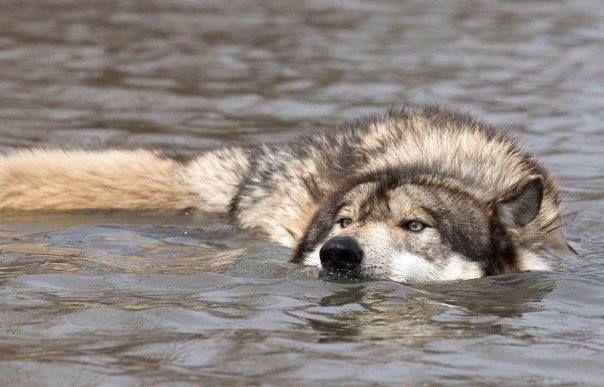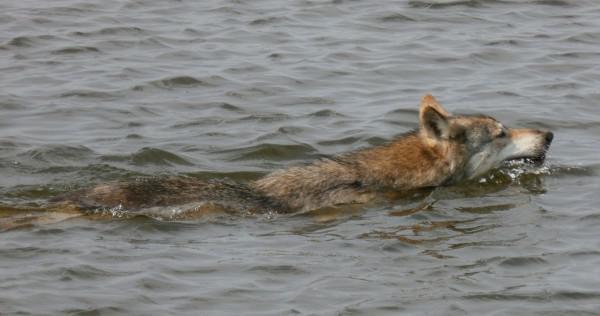The first image is the image on the left, the second image is the image on the right. For the images displayed, is the sentence "In the right image, one wolf has its open jaw around part of a wolf pup." factually correct? Answer yes or no. No. The first image is the image on the left, the second image is the image on the right. Analyze the images presented: Is the assertion "There is a wolf in the water." valid? Answer yes or no. Yes. 